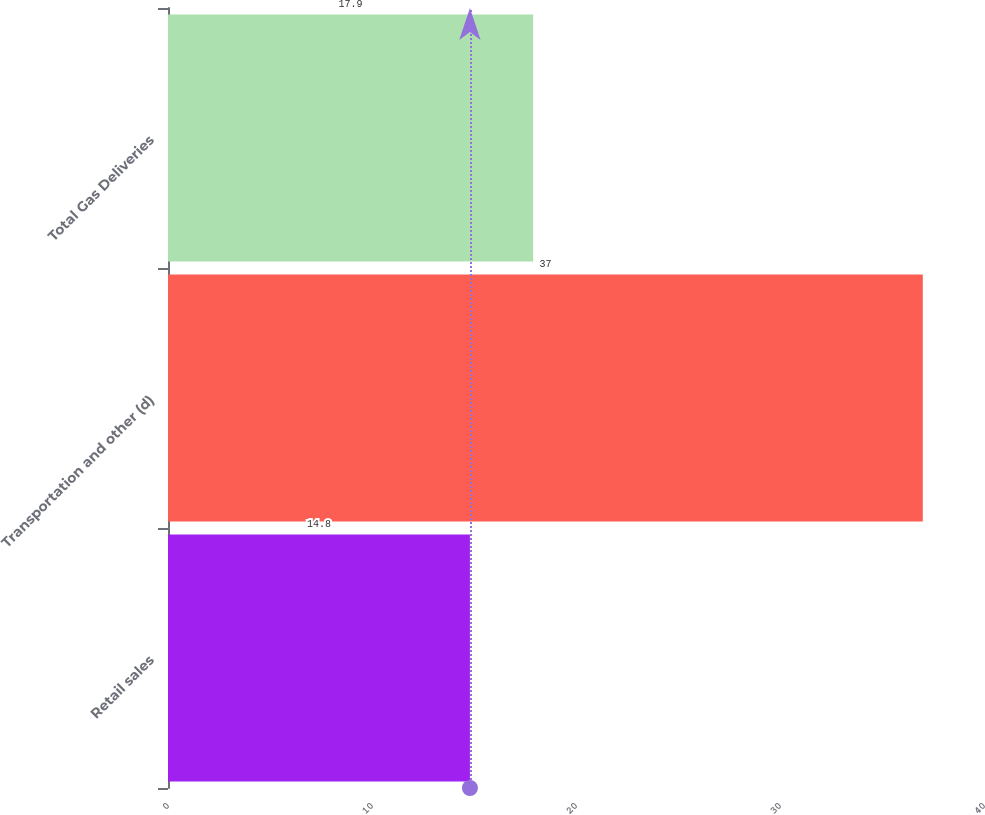Convert chart. <chart><loc_0><loc_0><loc_500><loc_500><bar_chart><fcel>Retail sales<fcel>Transportation and other (d)<fcel>Total Gas Deliveries<nl><fcel>14.8<fcel>37<fcel>17.9<nl></chart> 